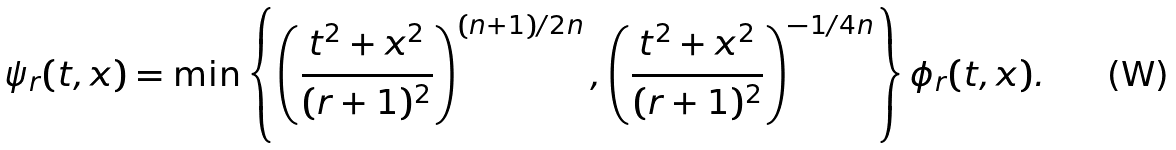Convert formula to latex. <formula><loc_0><loc_0><loc_500><loc_500>\psi _ { r } ( t , x ) = \min \left \{ \left ( \frac { t ^ { 2 } + x ^ { 2 } } { ( r + 1 ) ^ { 2 } } \right ) ^ { ( n + 1 ) / 2 n } , \left ( \frac { t ^ { 2 } + x ^ { 2 } } { ( r + 1 ) ^ { 2 } } \right ) ^ { - 1 / 4 n } \right \} \phi _ { r } ( t , x ) .</formula> 